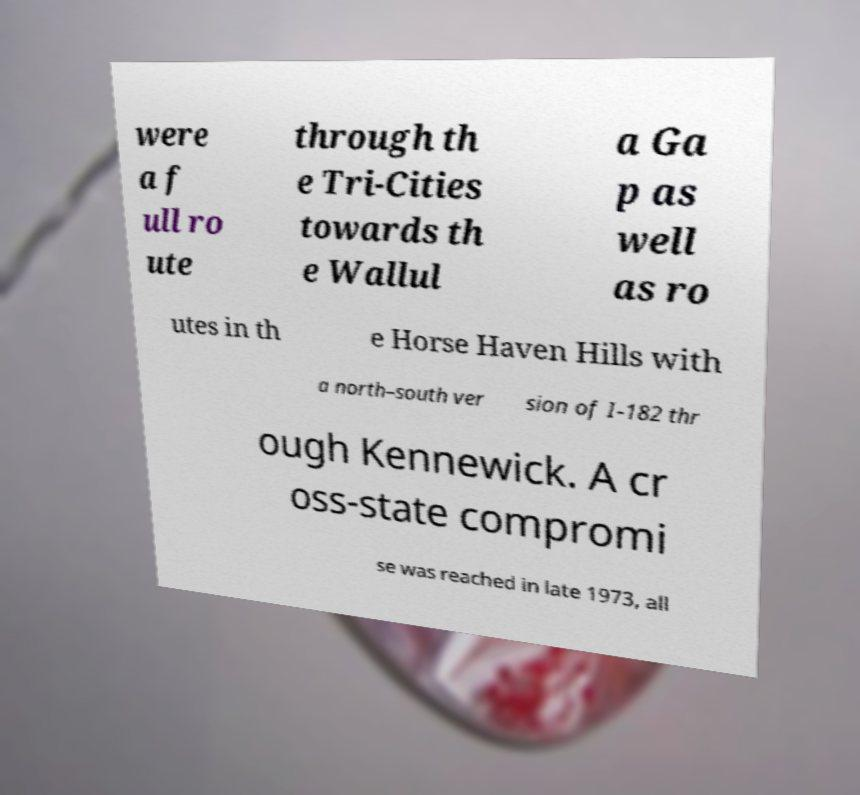Can you read and provide the text displayed in the image?This photo seems to have some interesting text. Can you extract and type it out for me? were a f ull ro ute through th e Tri-Cities towards th e Wallul a Ga p as well as ro utes in th e Horse Haven Hills with a north–south ver sion of I-182 thr ough Kennewick. A cr oss-state compromi se was reached in late 1973, all 